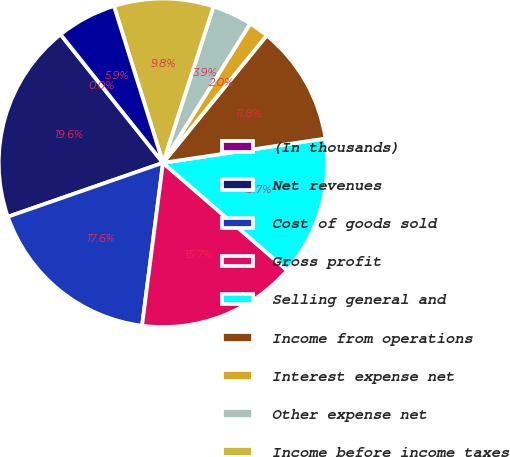Convert chart to OTSL. <chart><loc_0><loc_0><loc_500><loc_500><pie_chart><fcel>(In thousands)<fcel>Net revenues<fcel>Cost of goods sold<fcel>Gross profit<fcel>Selling general and<fcel>Income from operations<fcel>Interest expense net<fcel>Other expense net<fcel>Income before income taxes<fcel>Provision for income taxes<nl><fcel>0.01%<fcel>19.6%<fcel>17.64%<fcel>15.68%<fcel>13.72%<fcel>11.76%<fcel>1.97%<fcel>3.93%<fcel>9.8%<fcel>5.89%<nl></chart> 